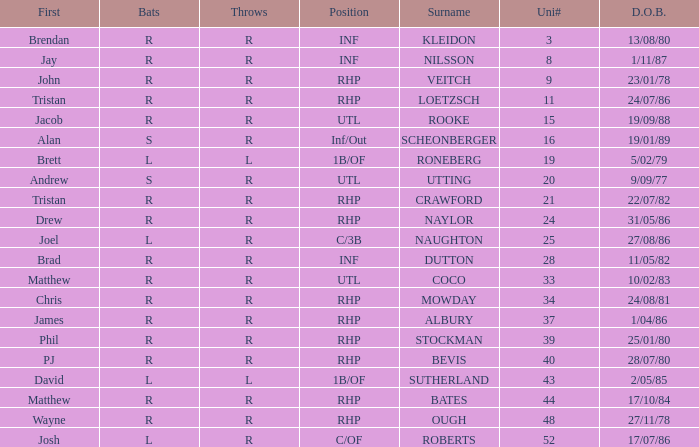How many Uni numbers have Bats of s, and a Position of utl? 1.0. 